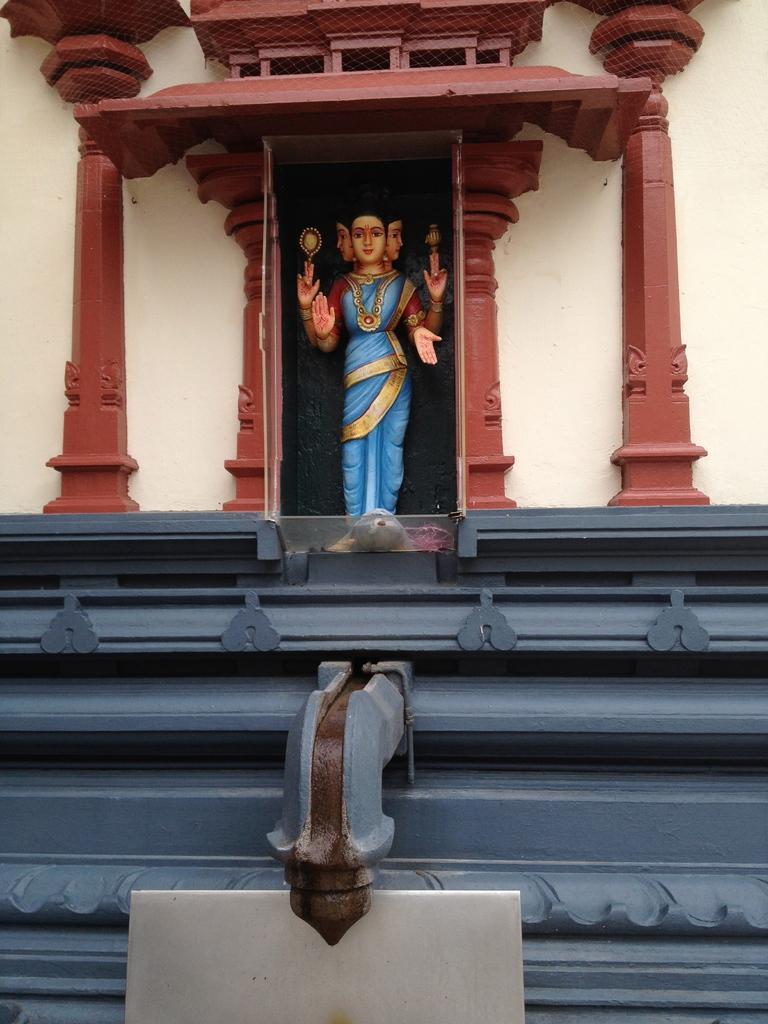Describe this image in one or two sentences. In this picture we can see a statue on a platform, here we can see a wall and some objects. 